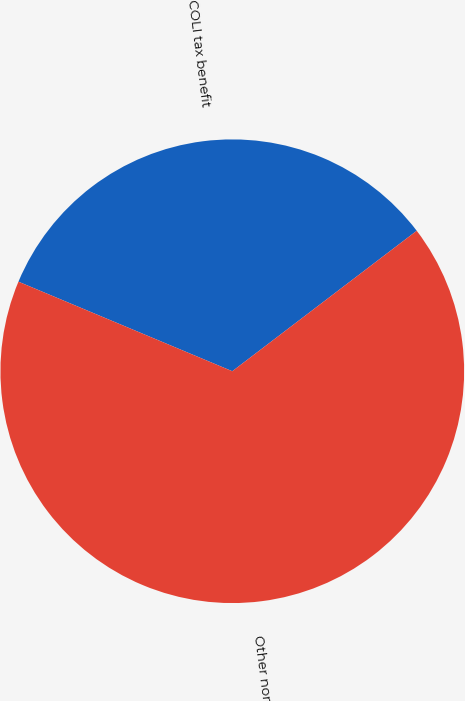Convert chart to OTSL. <chart><loc_0><loc_0><loc_500><loc_500><pie_chart><fcel>COLI tax benefit<fcel>Other nonregulated<nl><fcel>33.33%<fcel>66.67%<nl></chart> 